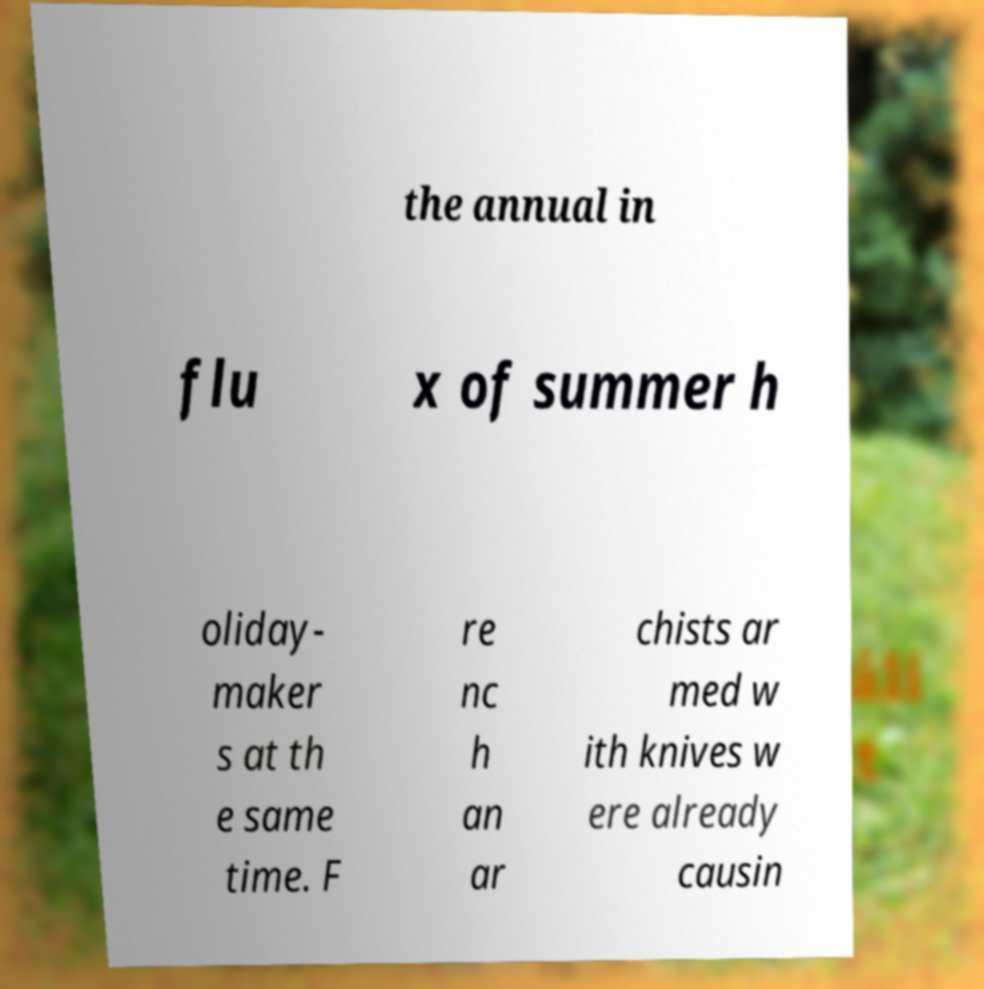Please identify and transcribe the text found in this image. the annual in flu x of summer h oliday- maker s at th e same time. F re nc h an ar chists ar med w ith knives w ere already causin 